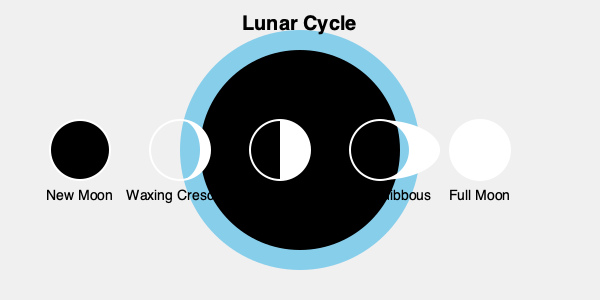In your documentary about lunar phenomena, you need to explain the phases of the moon. Which phase occurs immediately after the New Moon, and what percentage of the moon's illuminated surface is visible from Earth during this phase? To answer this question, let's break down the lunar cycle:

1. The lunar cycle begins with the New Moon, where the moon is not visible from Earth.

2. After the New Moon, the moon enters the Waxing Crescent phase.

3. During the Waxing Crescent phase:
   - The moon appears as a thin crescent shape.
   - The illuminated portion gradually increases from right to left (in the Northern Hemisphere).
   - This phase lasts for about 3-4 days after the New Moon.

4. The percentage of the moon's illuminated surface visible during the Waxing Crescent phase:
   - Starts at about 0.1% just after the New Moon.
   - Increases to approximately 49.9% just before the First Quarter.
   - On average, about 1-25% of the moon's surface is visible during this phase.

5. The exact percentage varies depending on the specific day within the Waxing Crescent phase, but it's always less than 50%.

Therefore, the phase immediately after the New Moon is the Waxing Crescent, with approximately 1-25% of the moon's illuminated surface visible from Earth.
Answer: Waxing Crescent; 1-25% 